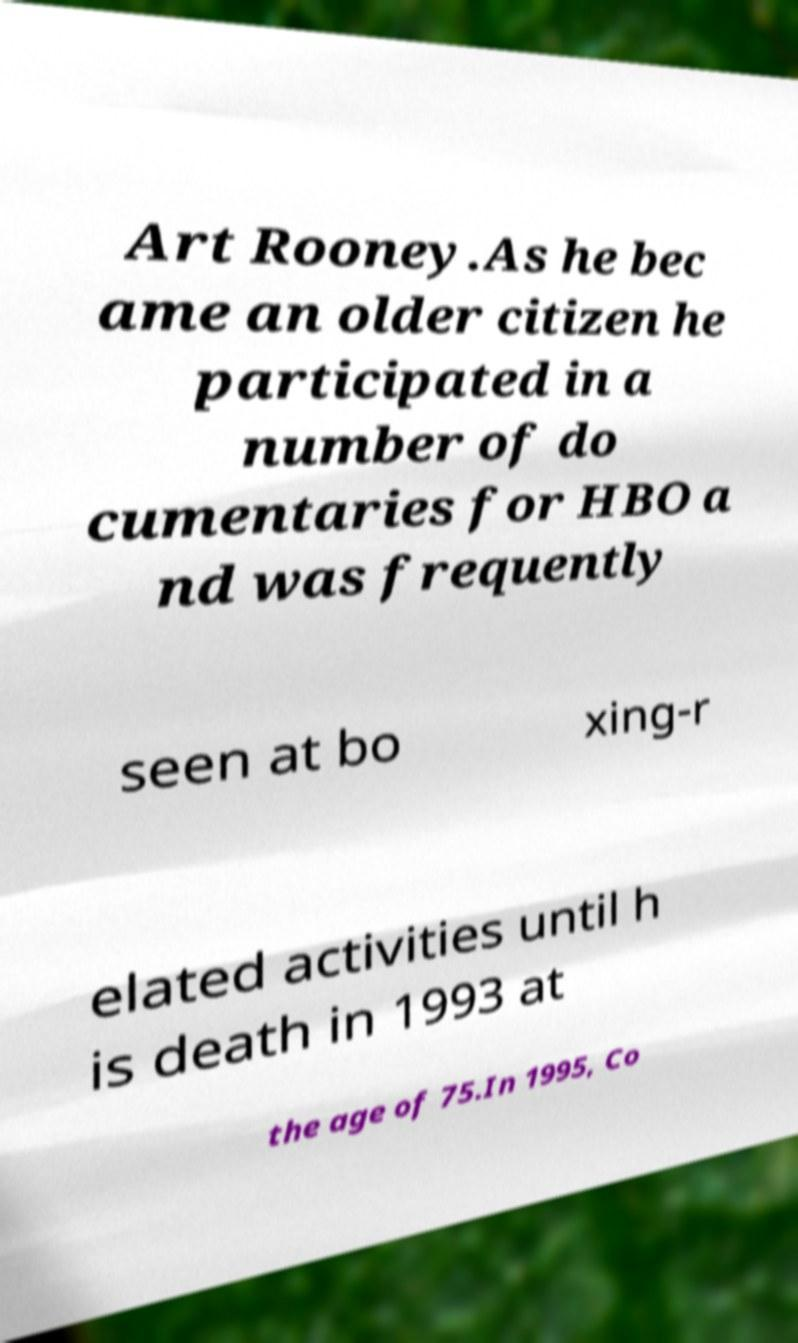Please read and relay the text visible in this image. What does it say? Art Rooney.As he bec ame an older citizen he participated in a number of do cumentaries for HBO a nd was frequently seen at bo xing-r elated activities until h is death in 1993 at the age of 75.In 1995, Co 